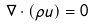<formula> <loc_0><loc_0><loc_500><loc_500>\nabla \cdot ( \rho { u } ) = 0</formula> 